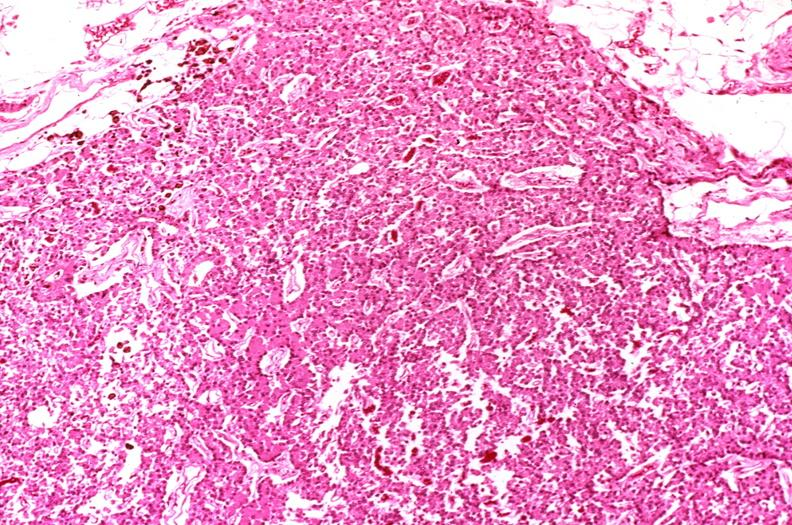s endocrine present?
Answer the question using a single word or phrase. Yes 